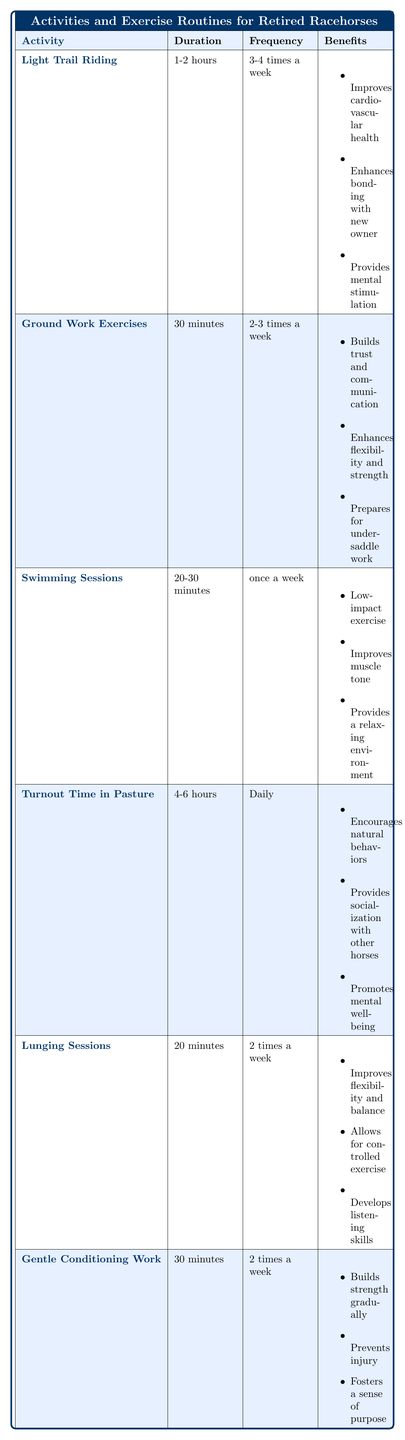What is the duration of Light Trail Riding? The table lists the duration of Light Trail Riding as "1-2 hours."
Answer: 1-2 hours How often should Ground Work Exercises be done? According to the table, Ground Work Exercises should be done "2-3 times a week."
Answer: 2-3 times a week Is Swimming Sessions a high-impact exercise? The table indicates that Swimming Sessions provide "low-impact exercise," which means it is not high-impact.
Answer: No What benefits are associated with Turnout Time in Pasture? The table lists three benefits: "Encourages natural behaviors," "Provides socialization with other horses," "Promotes mental well-being."
Answer: Encourages natural behaviors, Provides socialization with other horses, Promotes mental well-being What is the total duration of exercises performed weekly if a horse participates in all activities listed for the maximum frequency? For maximum frequency, the total is calculated as follows: Light Trail Riding (2 hours) x 4 = 8 hours, Ground Work (30 minutes) x 3 = 1.5 hours, Swimming (30 minutes) x 1 = 0.5 hours, Turnout Time (6 hours) x 7 = 42 hours, Lunging (20 minutes) x 2 = 0.67 hours, and Gentle Conditioning (30 minutes) x 2 = 1 hour. Adding these: 8 + 1.5 + 0.5 + 42 + 0.67 + 1 = 54.67 hours per week.
Answer: 54.67 hours How many activities can be performed daily based on the table? The table shows activities that can be completed daily (Turnout Time in Pasture), which means only one activity is indicated for daily frequency.
Answer: 1 activity 